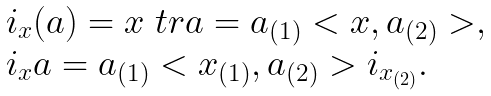Convert formula to latex. <formula><loc_0><loc_0><loc_500><loc_500>\begin{array} { l } \L i _ { x } ( a ) = x \ t r a = a _ { ( 1 ) } < x , a _ { ( 2 ) } > , \\ \L i _ { x } a = a _ { ( 1 ) } < x _ { ( 1 ) } , a _ { ( 2 ) } > \L i _ { x _ { ( 2 ) } } . \end{array}</formula> 